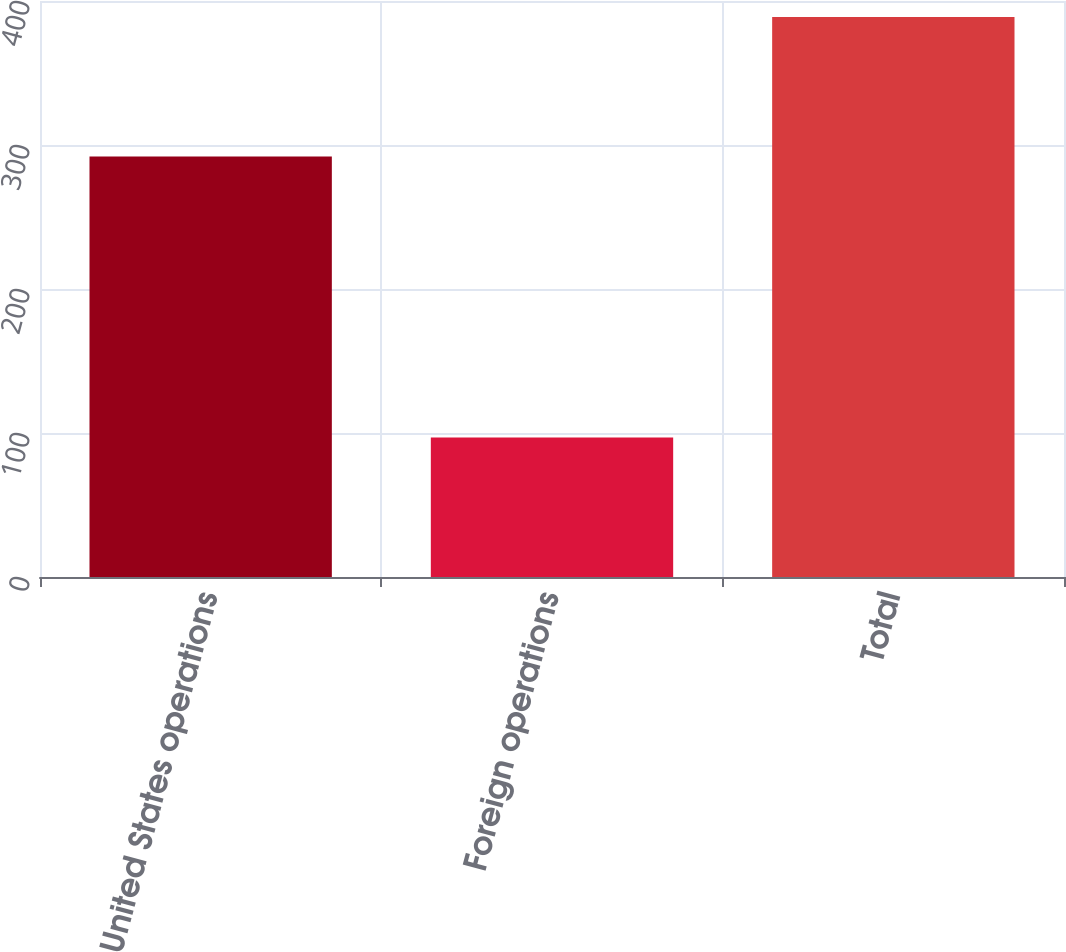Convert chart to OTSL. <chart><loc_0><loc_0><loc_500><loc_500><bar_chart><fcel>United States operations<fcel>Foreign operations<fcel>Total<nl><fcel>292<fcel>96.9<fcel>388.9<nl></chart> 